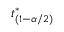<formula> <loc_0><loc_0><loc_500><loc_500>t _ { ( 1 - \alpha / 2 ) } ^ { * }</formula> 